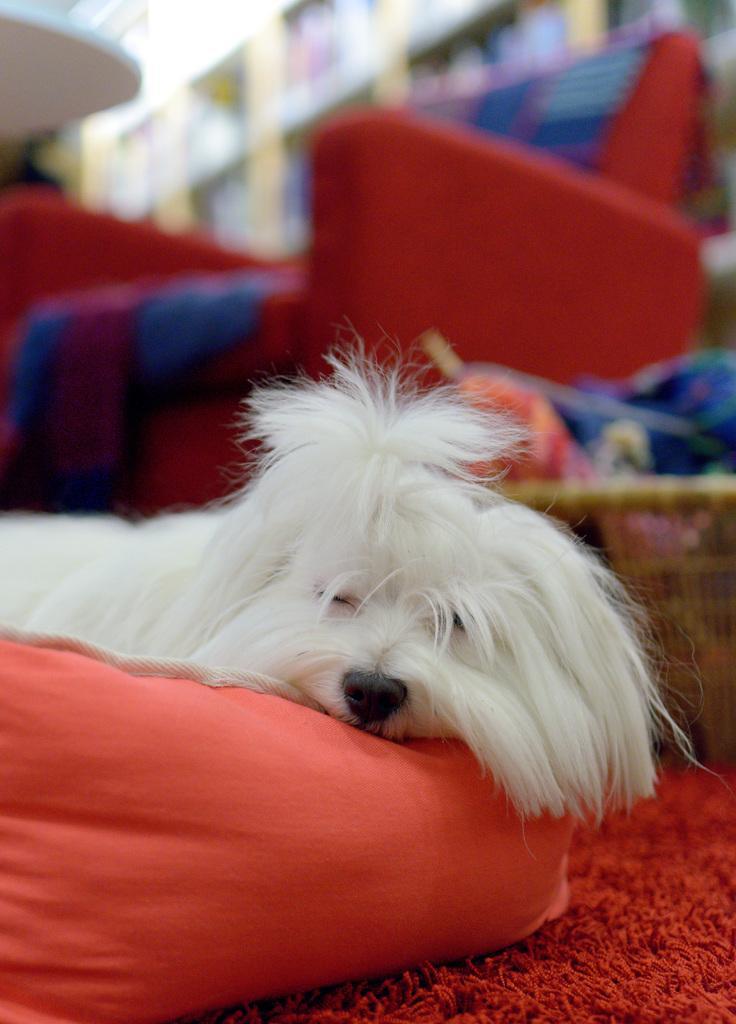Describe this image in one or two sentences. In this image there is one white color dog is lying on one object is on the bottom of this image and there is a chair in middle of this image. There is a rack on the top of this image. 